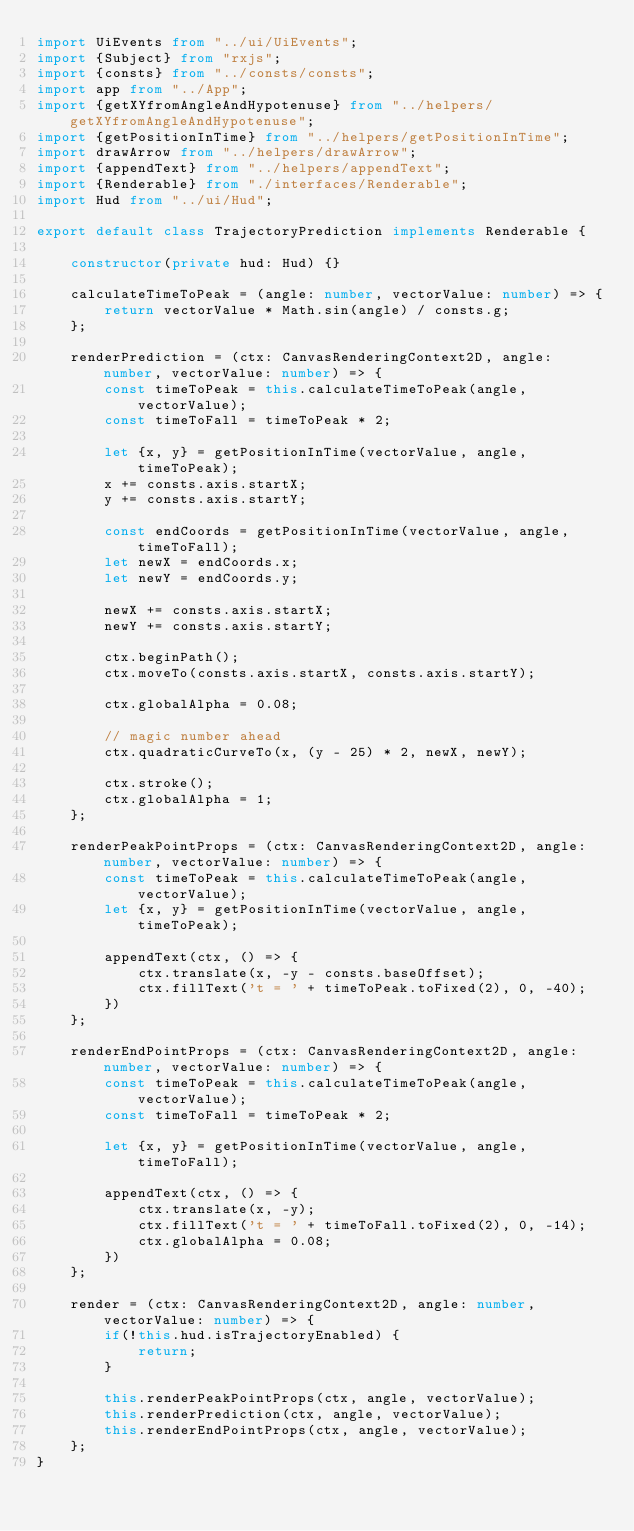<code> <loc_0><loc_0><loc_500><loc_500><_TypeScript_>import UiEvents from "../ui/UiEvents";
import {Subject} from "rxjs";
import {consts} from "../consts/consts";
import app from "../App";
import {getXYfromAngleAndHypotenuse} from "../helpers/getXYfromAngleAndHypotenuse";
import {getPositionInTime} from "../helpers/getPositionInTime";
import drawArrow from "../helpers/drawArrow";
import {appendText} from "../helpers/appendText";
import {Renderable} from "./interfaces/Renderable";
import Hud from "../ui/Hud";

export default class TrajectoryPrediction implements Renderable {

    constructor(private hud: Hud) {}

    calculateTimeToPeak = (angle: number, vectorValue: number) => {
        return vectorValue * Math.sin(angle) / consts.g;
    };

    renderPrediction = (ctx: CanvasRenderingContext2D, angle: number, vectorValue: number) => {
        const timeToPeak = this.calculateTimeToPeak(angle, vectorValue);
        const timeToFall = timeToPeak * 2;

        let {x, y} = getPositionInTime(vectorValue, angle, timeToPeak);
        x += consts.axis.startX;
        y += consts.axis.startY;

        const endCoords = getPositionInTime(vectorValue, angle, timeToFall);
        let newX = endCoords.x;
        let newY = endCoords.y;

        newX += consts.axis.startX;
        newY += consts.axis.startY;

        ctx.beginPath();
        ctx.moveTo(consts.axis.startX, consts.axis.startY);

        ctx.globalAlpha = 0.08;

        // magic number ahead
        ctx.quadraticCurveTo(x, (y - 25) * 2, newX, newY);

        ctx.stroke();
        ctx.globalAlpha = 1;
    };

    renderPeakPointProps = (ctx: CanvasRenderingContext2D, angle: number, vectorValue: number) => {
        const timeToPeak = this.calculateTimeToPeak(angle, vectorValue);
        let {x, y} = getPositionInTime(vectorValue, angle, timeToPeak);

        appendText(ctx, () => {
            ctx.translate(x, -y - consts.baseOffset);
            ctx.fillText('t = ' + timeToPeak.toFixed(2), 0, -40);
        })
    };

    renderEndPointProps = (ctx: CanvasRenderingContext2D, angle: number, vectorValue: number) => {
        const timeToPeak = this.calculateTimeToPeak(angle, vectorValue);
        const timeToFall = timeToPeak * 2;

        let {x, y} = getPositionInTime(vectorValue, angle, timeToFall);

        appendText(ctx, () => {
            ctx.translate(x, -y);
            ctx.fillText('t = ' + timeToFall.toFixed(2), 0, -14);
            ctx.globalAlpha = 0.08;
        })
    };

    render = (ctx: CanvasRenderingContext2D, angle: number, vectorValue: number) => {
        if(!this.hud.isTrajectoryEnabled) {
            return;
        }

        this.renderPeakPointProps(ctx, angle, vectorValue);
        this.renderPrediction(ctx, angle, vectorValue);
        this.renderEndPointProps(ctx, angle, vectorValue);
    };
}</code> 